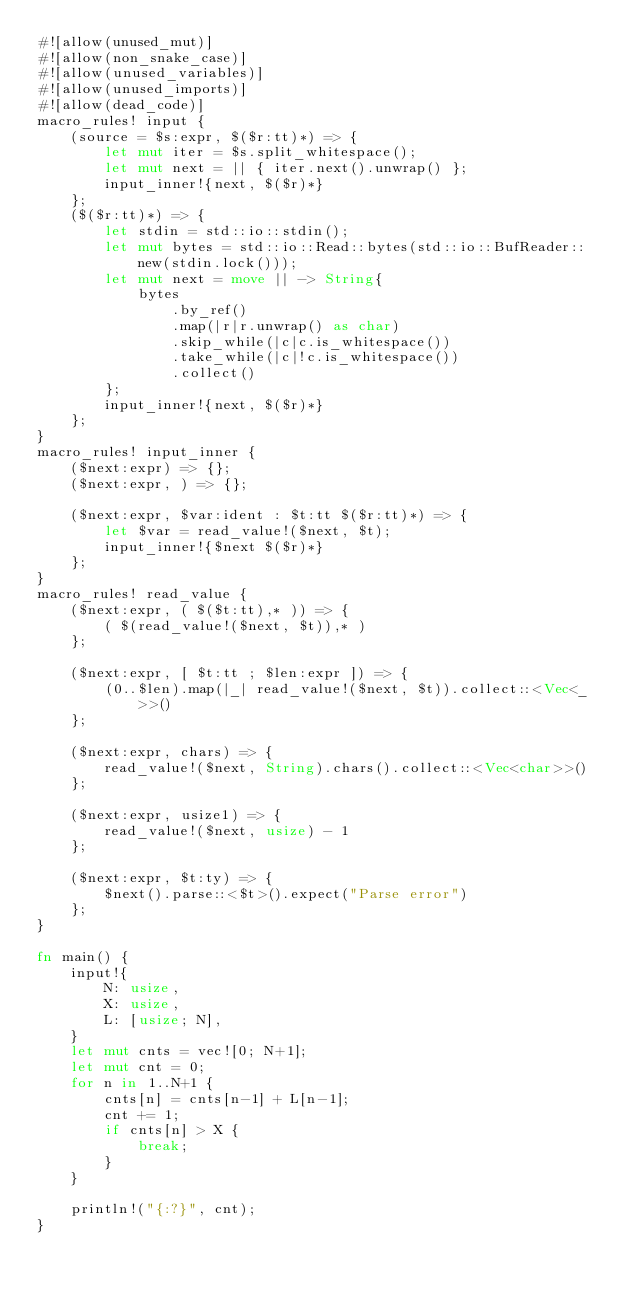Convert code to text. <code><loc_0><loc_0><loc_500><loc_500><_Rust_>#![allow(unused_mut)]
#![allow(non_snake_case)]
#![allow(unused_variables)]
#![allow(unused_imports)]
#![allow(dead_code)]
macro_rules! input {
    (source = $s:expr, $($r:tt)*) => {
        let mut iter = $s.split_whitespace();
        let mut next = || { iter.next().unwrap() };
        input_inner!{next, $($r)*}
    };
    ($($r:tt)*) => {
        let stdin = std::io::stdin();
        let mut bytes = std::io::Read::bytes(std::io::BufReader::new(stdin.lock()));
        let mut next = move || -> String{
            bytes
                .by_ref()
                .map(|r|r.unwrap() as char)
                .skip_while(|c|c.is_whitespace())
                .take_while(|c|!c.is_whitespace())
                .collect()
        };
        input_inner!{next, $($r)*}
    };
}
macro_rules! input_inner {
    ($next:expr) => {};
    ($next:expr, ) => {};

    ($next:expr, $var:ident : $t:tt $($r:tt)*) => {
        let $var = read_value!($next, $t);
        input_inner!{$next $($r)*}
    };
}
macro_rules! read_value {
    ($next:expr, ( $($t:tt),* )) => {
        ( $(read_value!($next, $t)),* )
    };

    ($next:expr, [ $t:tt ; $len:expr ]) => {
        (0..$len).map(|_| read_value!($next, $t)).collect::<Vec<_>>()
    };

    ($next:expr, chars) => {
        read_value!($next, String).chars().collect::<Vec<char>>()
    };

    ($next:expr, usize1) => {
        read_value!($next, usize) - 1
    };

    ($next:expr, $t:ty) => {
        $next().parse::<$t>().expect("Parse error")
    };
}

fn main() {
    input!{
        N: usize,
        X: usize,
        L: [usize; N],
    }
    let mut cnts = vec![0; N+1];
    let mut cnt = 0;
    for n in 1..N+1 {
        cnts[n] = cnts[n-1] + L[n-1];
        cnt += 1;
        if cnts[n] > X {
            break;
        }
    }

    println!("{:?}", cnt);
}

</code> 